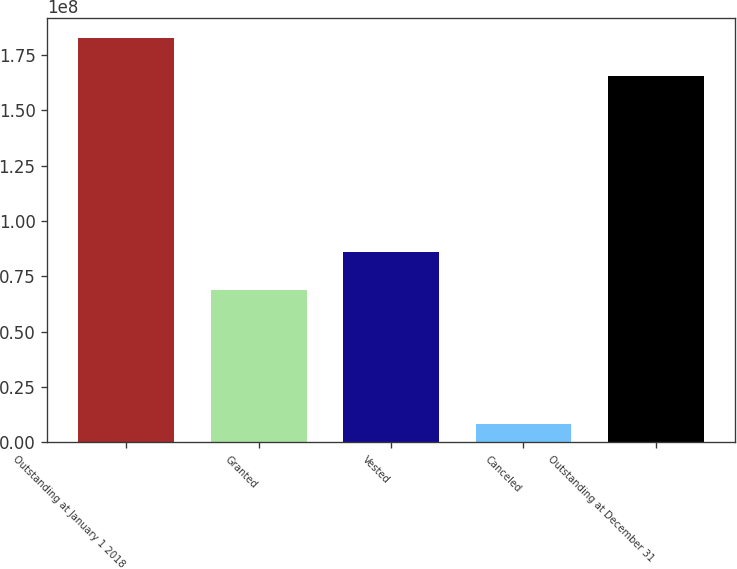Convert chart. <chart><loc_0><loc_0><loc_500><loc_500><bar_chart><fcel>Outstanding at January 1 2018<fcel>Granted<fcel>Vested<fcel>Canceled<fcel>Outstanding at December 31<nl><fcel>1.82729e+08<fcel>6.88996e+07<fcel>8.60076e+07<fcel>8.194e+06<fcel>1.65621e+08<nl></chart> 